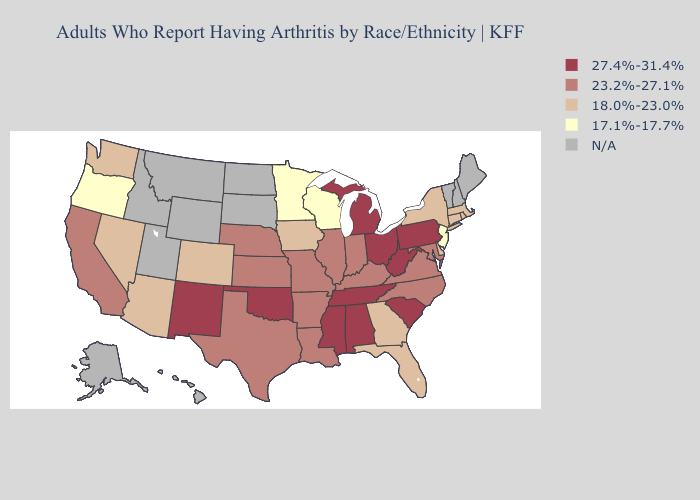What is the lowest value in states that border Michigan?
Quick response, please. 17.1%-17.7%. What is the highest value in the Northeast ?
Concise answer only. 27.4%-31.4%. Does Oklahoma have the highest value in the USA?
Be succinct. Yes. How many symbols are there in the legend?
Give a very brief answer. 5. What is the highest value in the MidWest ?
Concise answer only. 27.4%-31.4%. What is the value of Tennessee?
Concise answer only. 27.4%-31.4%. Name the states that have a value in the range 27.4%-31.4%?
Quick response, please. Alabama, Michigan, Mississippi, New Mexico, Ohio, Oklahoma, Pennsylvania, South Carolina, Tennessee, West Virginia. Name the states that have a value in the range 17.1%-17.7%?
Quick response, please. Minnesota, New Jersey, Oregon, Wisconsin. Name the states that have a value in the range 18.0%-23.0%?
Concise answer only. Arizona, Colorado, Connecticut, Delaware, Florida, Georgia, Iowa, Massachusetts, Nevada, New York, Rhode Island, Washington. What is the highest value in the USA?
Answer briefly. 27.4%-31.4%. What is the value of Connecticut?
Keep it brief. 18.0%-23.0%. Does Georgia have the highest value in the USA?
Keep it brief. No. Name the states that have a value in the range N/A?
Keep it brief. Alaska, Hawaii, Idaho, Maine, Montana, New Hampshire, North Dakota, South Dakota, Utah, Vermont, Wyoming. Name the states that have a value in the range 23.2%-27.1%?
Short answer required. Arkansas, California, Illinois, Indiana, Kansas, Kentucky, Louisiana, Maryland, Missouri, Nebraska, North Carolina, Texas, Virginia. What is the value of Minnesota?
Answer briefly. 17.1%-17.7%. 